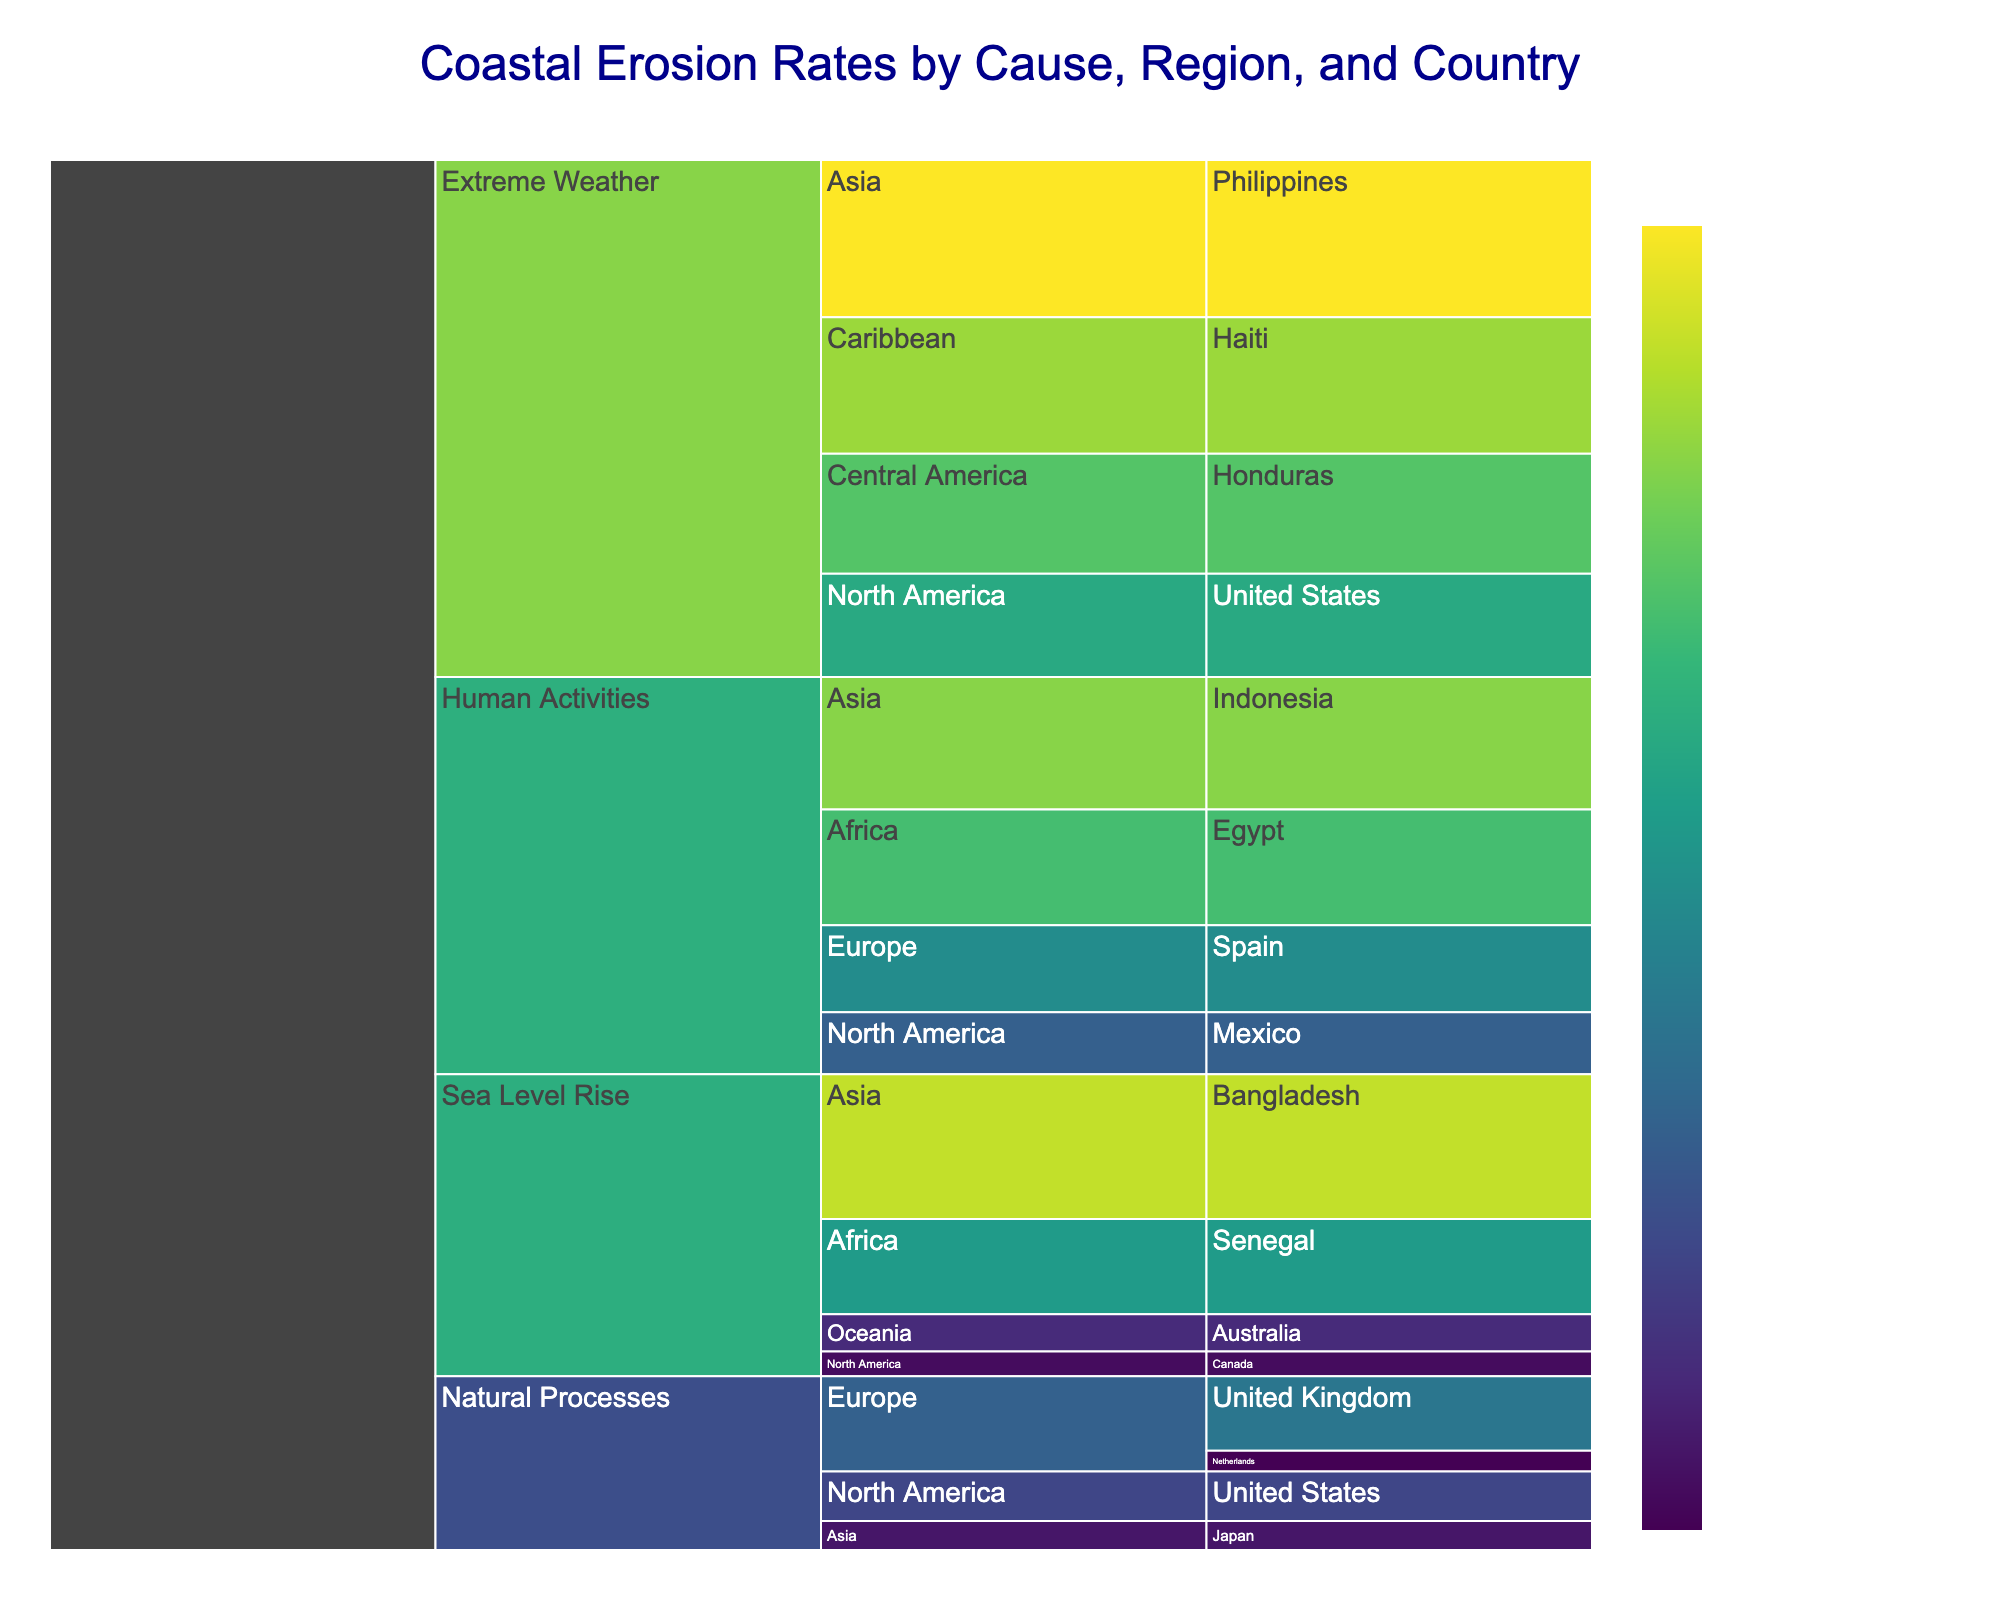What is the primary cause category with the highest coastal erosion rate? Look at the different cause categories and identify the one with the highest numerical value for erosion rates. The "Extreme Weather" category has erosion rates up to 3.8 m/year, which is the highest among all causes.
Answer: Extreme Weather Which country in the "Human Activities" category has the highest erosion rate? Review the "Human Activities" section and compare erosion rates for each country. Indonesia has the highest rate at 3.2 m/year.
Answer: Indonesia Which region in the "Sea Level Rise" category has the lowest erosion rate? Locate the "Sea Level Rise" section, and identify the regions. Compare their erosion rates to find the lowest one. Canada in North America has the lowest rate at 0.6 m/year.
Answer: North America (Canada) How does the erosion rate in the United States compare between "Natural Processes" and "Extreme Weather"? Find the erosion rates for the United States under both "Natural Processes" (1.2 m/year) and "Extreme Weather" (2.5 m/year) and compare them. The rate under "Extreme Weather" is higher.
Answer: Higher under Extreme Weather What is the combined erosion rate for the "Sea Level Rise" category across all regions? Sum the erosion rates for each region within the "Sea Level Rise" category: Australia (0.9) + Canada (0.6) + Bangladesh (3.5) + Senegal (2.3). The total is 7.3 m/year.
Answer: 7.3 m/year Which region within the "Extreme Weather" category has the highest individual country erosion rate? Check the countries listed under the "Extreme Weather" category and compare their erosion rates. The Philippines in Asia has the highest rate at 3.8 m/year.
Answer: Asia (Philippines) What's the average erosion rate for countries in Europe due to "Natural Processes"? Add the erosion rates for the United Kingdom (1.8) and the Netherlands (0.5) and then divide by the number of countries (2). The average is (1.8 + 0.5) / 2 = 1.15 m/year.
Answer: 1.15 m/year Which country under "Extreme Weather" in the Caribbean has the highest erosion rate, and what is that rate? Identify the Caribbean countries within the "Extreme Weather" category and check their erosion rates. Haiti has the erosion rate of 3.3 m/year.
Answer: Haiti, 3.3 m/year Which cause category has the lowest overall erosion rate, and what is that rate? Compare the lowest rates within each cause category: Natural Processes (0.5 m/year in Netherlands), Human Activities (1.5 m/year in Mexico), Sea Level Rise (0.6 m/year in Canada), Extreme Weather (2.5 m/year in the United States). The lowest is 0.5 m/year from Natural Processes.
Answer: Natural Processes, 0.5 m/year 